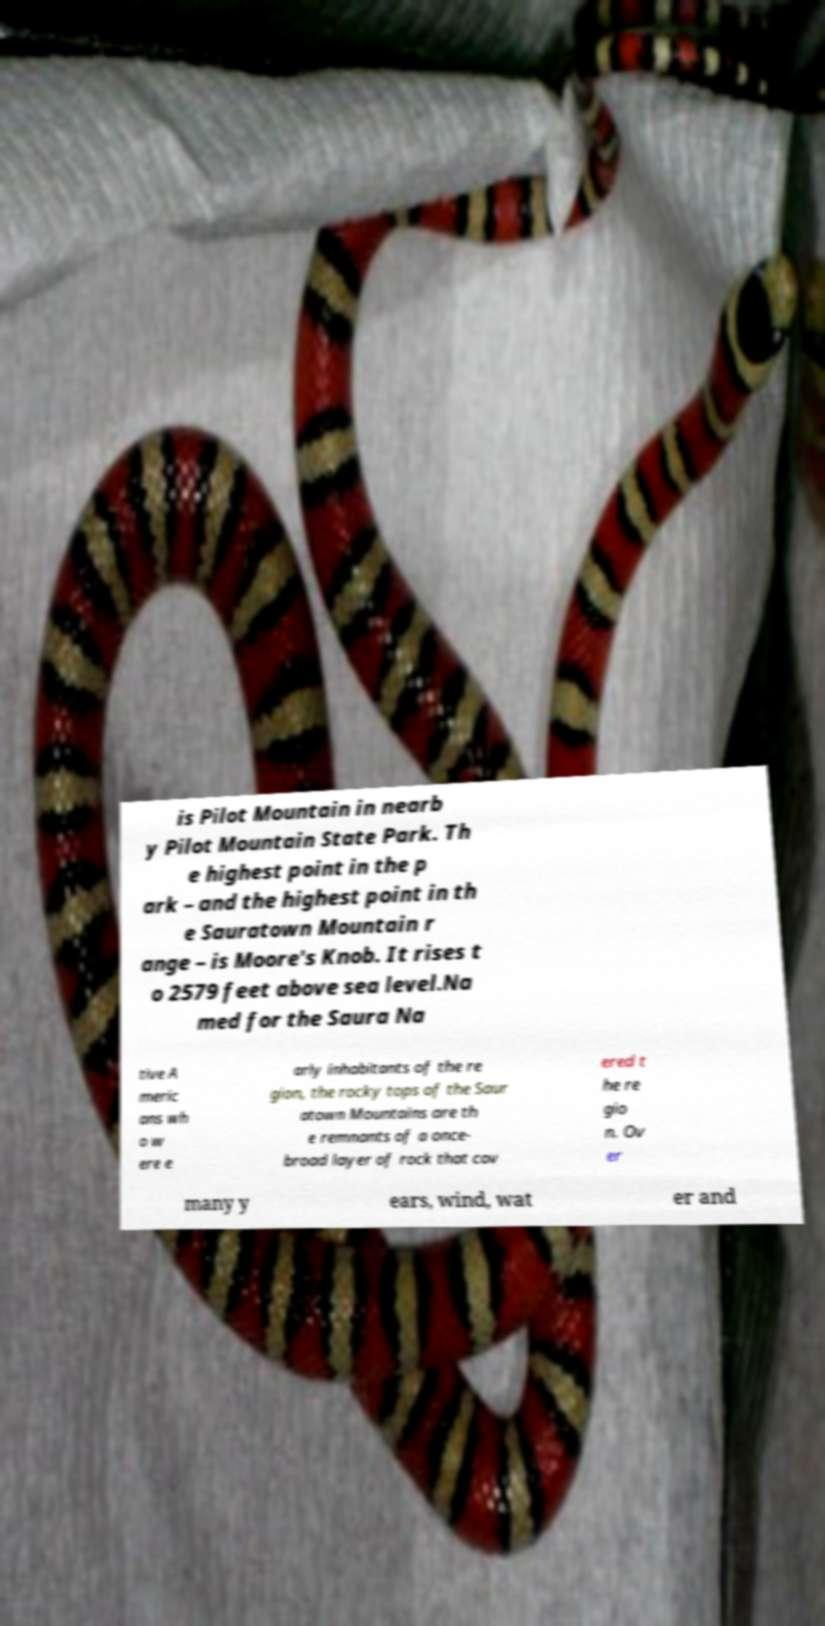I need the written content from this picture converted into text. Can you do that? is Pilot Mountain in nearb y Pilot Mountain State Park. Th e highest point in the p ark – and the highest point in th e Sauratown Mountain r ange – is Moore's Knob. It rises t o 2579 feet above sea level.Na med for the Saura Na tive A meric ans wh o w ere e arly inhabitants of the re gion, the rocky tops of the Saur atown Mountains are th e remnants of a once- broad layer of rock that cov ered t he re gio n. Ov er many y ears, wind, wat er and 